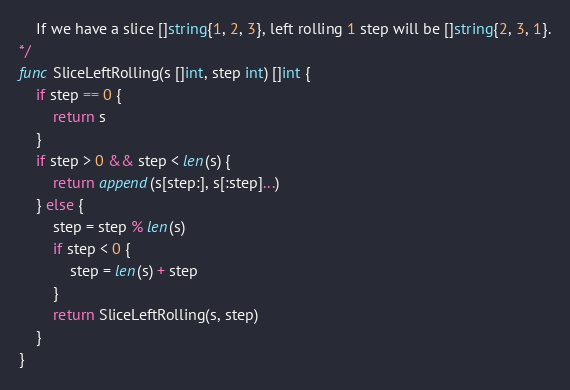<code> <loc_0><loc_0><loc_500><loc_500><_Go_>	If we have a slice []string{1, 2, 3}, left rolling 1 step will be []string{2, 3, 1}.
*/
func SliceLeftRolling(s []int, step int) []int {
	if step == 0 {
		return s
	}
	if step > 0 && step < len(s) {
		return append(s[step:], s[:step]...)
	} else {
		step = step % len(s)
		if step < 0 {
			step = len(s) + step
		}
		return SliceLeftRolling(s, step)
	}
}
</code> 